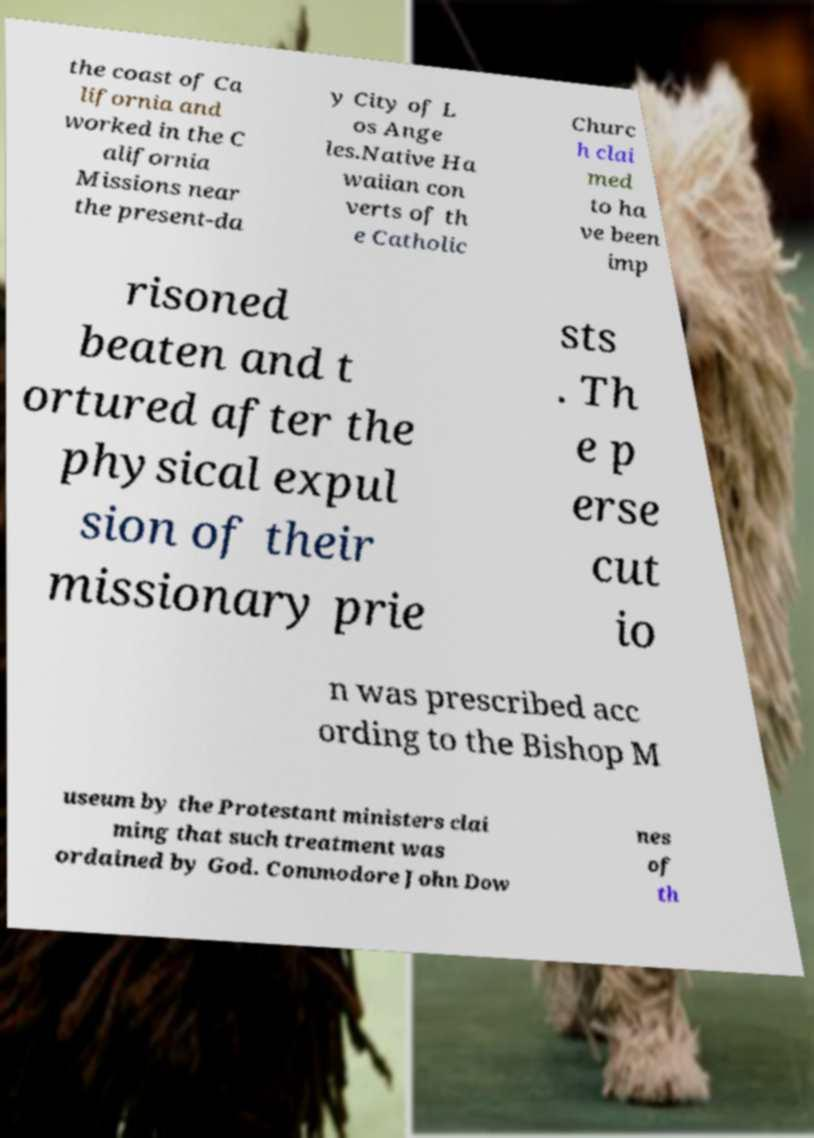Please read and relay the text visible in this image. What does it say? the coast of Ca lifornia and worked in the C alifornia Missions near the present-da y City of L os Ange les.Native Ha waiian con verts of th e Catholic Churc h clai med to ha ve been imp risoned beaten and t ortured after the physical expul sion of their missionary prie sts . Th e p erse cut io n was prescribed acc ording to the Bishop M useum by the Protestant ministers clai ming that such treatment was ordained by God. Commodore John Dow nes of th 